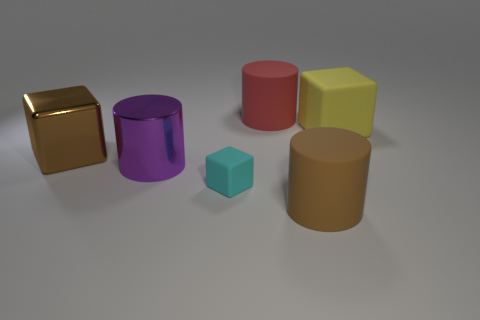Subtract 1 cylinders. How many cylinders are left? 2 Add 1 small purple matte blocks. How many objects exist? 7 Add 5 tiny blocks. How many tiny blocks exist? 6 Subtract 0 red cubes. How many objects are left? 6 Subtract all brown objects. Subtract all big purple metallic objects. How many objects are left? 3 Add 5 red matte objects. How many red matte objects are left? 6 